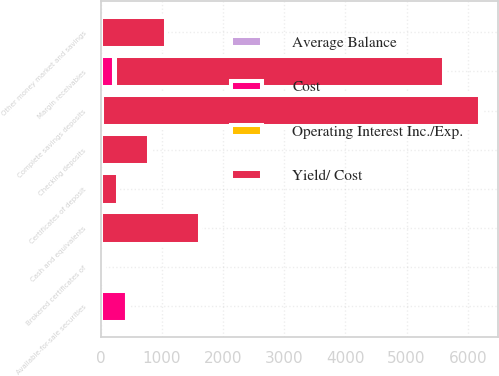Convert chart to OTSL. <chart><loc_0><loc_0><loc_500><loc_500><stacked_bar_chart><ecel><fcel>Margin receivables<fcel>Available-for-sale securities<fcel>Cash and equivalents<fcel>Complete savings deposits<fcel>Other money market and savings<fcel>Checking deposits<fcel>Certificates of deposit<fcel>Brokered certificates of<nl><fcel>Yield/ Cost<fcel>5374.8<fcel>3.2<fcel>1618.9<fcel>6174.4<fcel>1071.5<fcel>783.2<fcel>270.7<fcel>48.8<nl><fcel>Cost<fcel>221.7<fcel>422.5<fcel>3.2<fcel>16.1<fcel>2.5<fcel>0.8<fcel>7.3<fcel>2.7<nl><fcel>Average Balance<fcel>4.13<fcel>2.76<fcel>0.2<fcel>0.26<fcel>0.23<fcel>0.1<fcel>2.7<fcel>5.58<nl><fcel>Operating Interest Inc./Exp.<fcel>4.42<fcel>2.92<fcel>0.22<fcel>0.38<fcel>0.25<fcel>0.11<fcel>1.82<fcel>5.14<nl></chart> 